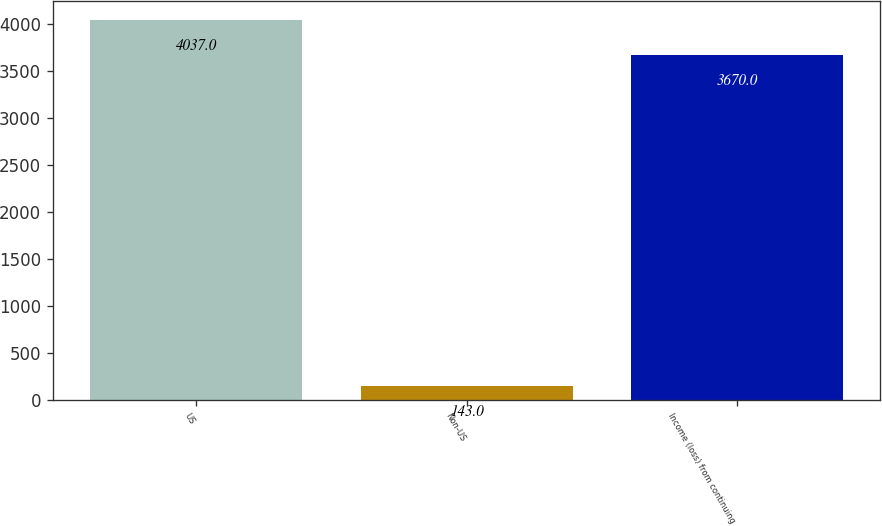Convert chart. <chart><loc_0><loc_0><loc_500><loc_500><bar_chart><fcel>US<fcel>Non-US<fcel>Income (loss) from continuing<nl><fcel>4037<fcel>143<fcel>3670<nl></chart> 